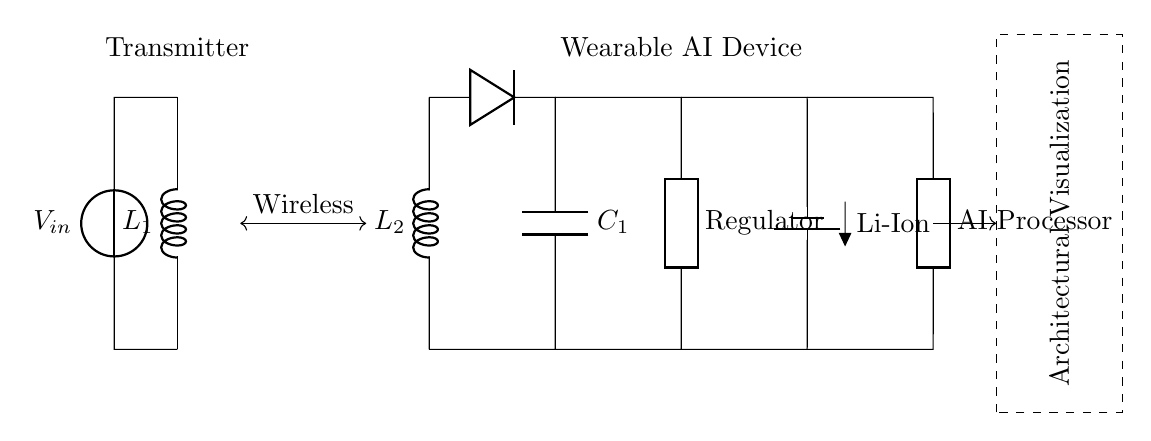what component is used for energy storage in the wearable AI device? The circuit indicates a capacitor labeled C1 which is typically used for energy storage. It smooths out fluctuations in voltage from the rectifier.
Answer: capacitor what type of battery is depicted in the circuit? The circuit diagram shows a battery labeled as a Li-Ion battery, which is commonly used in portable electronic devices due to its high energy density.
Answer: Li-Ion how many coils are present in the inductive charging circuit? The circuit contains two coils labeled L1 and L2, representing the primary and secondary coils used for inductive charging.
Answer: two what function does the regulator serve in this circuit? The voltage regulator regulates the output voltage from the rectifier to ensure that the wearable AI device receives a consistent voltage for proper functionality.
Answer: voltage regulation what is the purpose of the wireless coupling between the coils? The wireless coupling allows for the transfer of energy from the primary coil to the secondary coil without physical connections, enabling inductive charging.
Answer: energy transfer what is the primary function of the AI processor shown in the circuit? The AI processor processes data and executes tasks, making it a key component of the wearable AI device for architectural visualization applications.
Answer: data processing how is the energy from the primary coil transferred to the secondary coil? The energy transfer occurs via electromagnetic induction, where varying magnetic fields generated by the primary coil induce a voltage in the secondary coil.
Answer: electromagnetic induction 